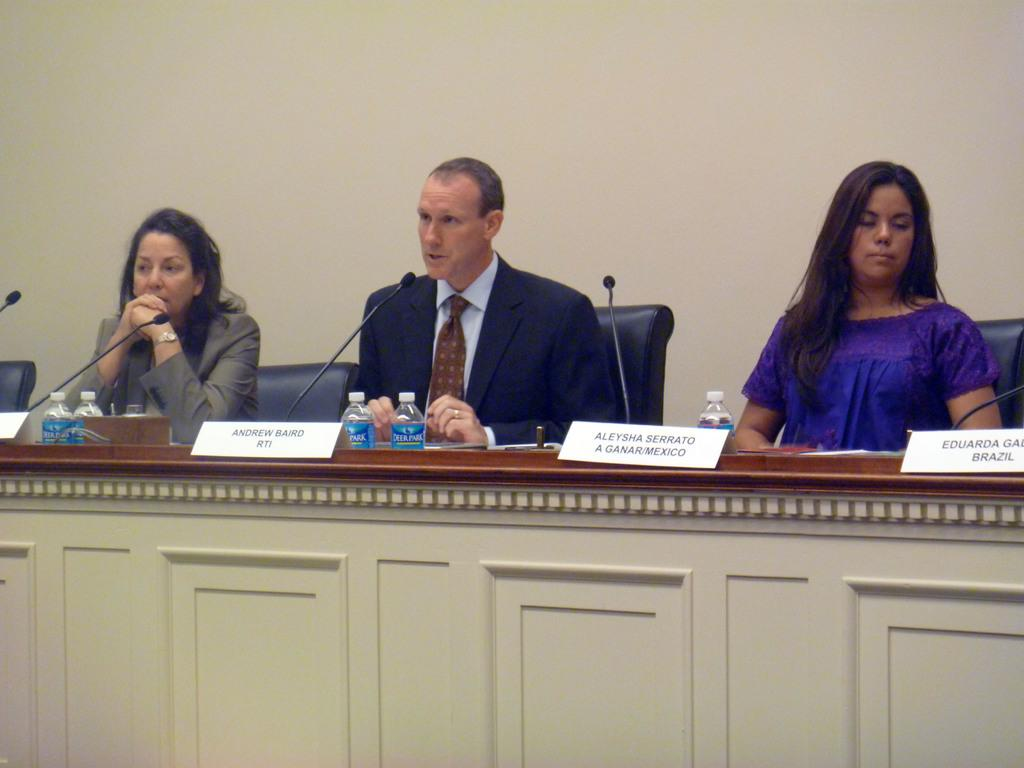How many people are sitting on chairs in the image? There are three persons sitting on chairs in the image. What is located in front of the chairs? There is a platform in front of the chairs. What can be seen on the platform? Name boards, bottles, and mics are present on the platform. What is visible in the background of the image? There is a wall in the background. What year is the son of the person sitting on the left chair born? There is no information about the person's son or their birth year in the image. 